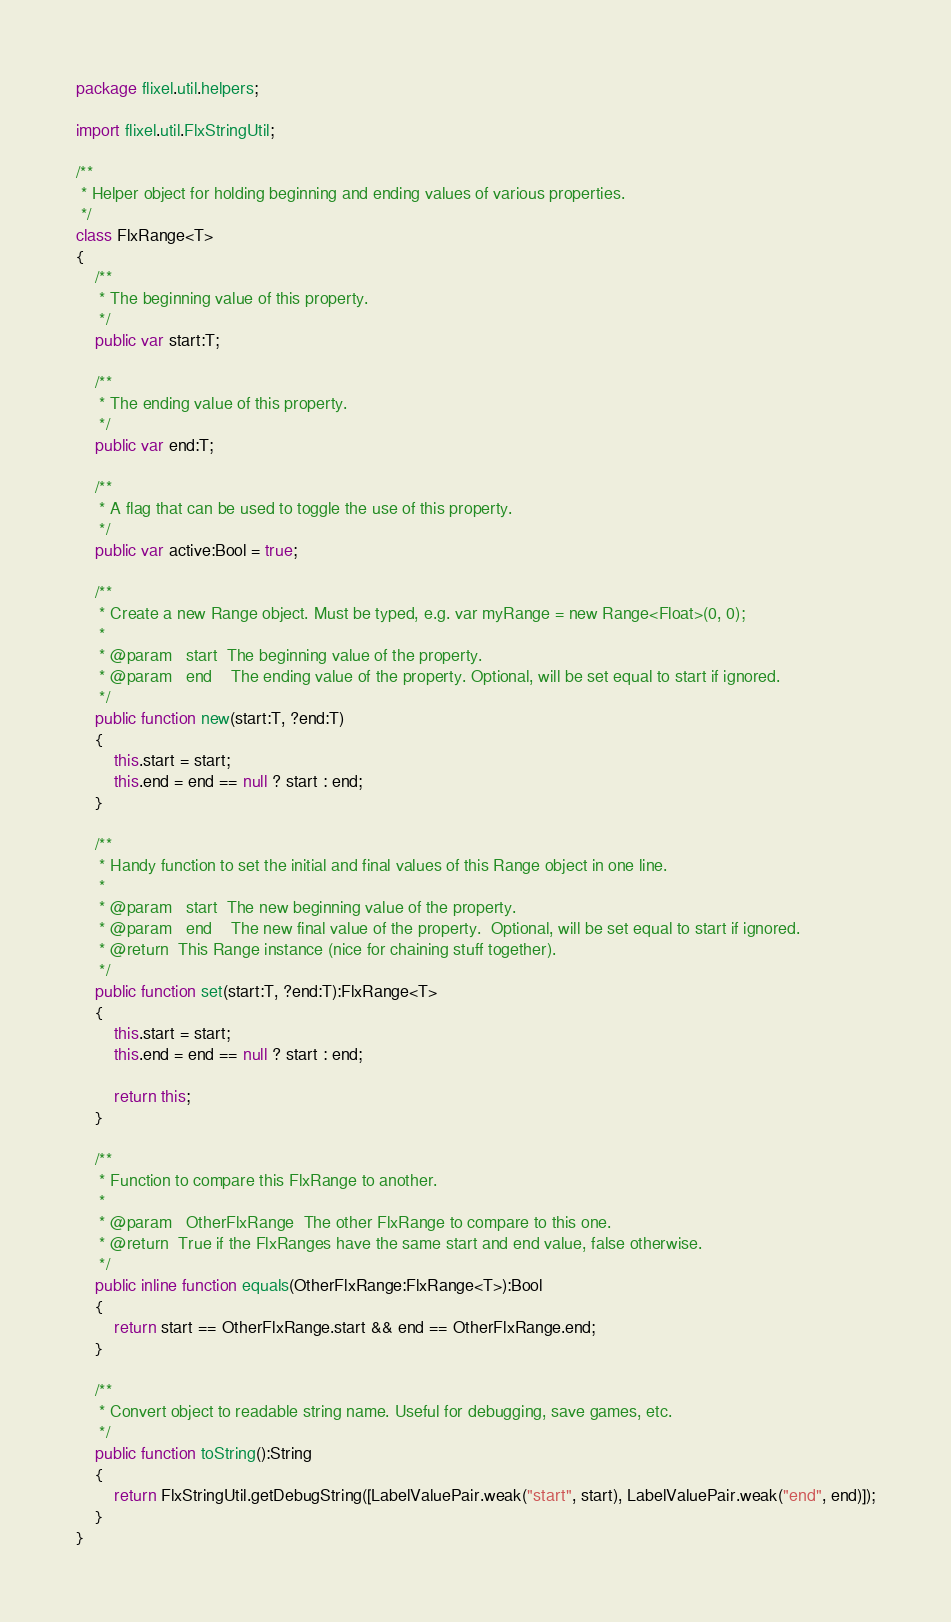<code> <loc_0><loc_0><loc_500><loc_500><_Haxe_>package flixel.util.helpers;

import flixel.util.FlxStringUtil;

/**
 * Helper object for holding beginning and ending values of various properties.
 */
class FlxRange<T>
{
	/**
	 * The beginning value of this property.
	 */
	public var start:T;

	/**
	 * The ending value of this property.
	 */
	public var end:T;

	/**
	 * A flag that can be used to toggle the use of this property.
	 */
	public var active:Bool = true;

	/**
	 * Create a new Range object. Must be typed, e.g. var myRange = new Range<Float>(0, 0);
	 *
	 * @param	start  The beginning value of the property.
	 * @param	end    The ending value of the property. Optional, will be set equal to start if ignored.
	 */
	public function new(start:T, ?end:T)
	{
		this.start = start;
		this.end = end == null ? start : end;
	}

	/**
	 * Handy function to set the initial and final values of this Range object in one line.
	 *
	 * @param	start  The new beginning value of the property.
	 * @param	end    The new final value of the property.  Optional, will be set equal to start if ignored.
	 * @return  This Range instance (nice for chaining stuff together).
	 */
	public function set(start:T, ?end:T):FlxRange<T>
	{
		this.start = start;
		this.end = end == null ? start : end;

		return this;
	}

	/**
	 * Function to compare this FlxRange to another.
	 *
	 * @param	OtherFlxRange  The other FlxRange to compare to this one.
	 * @return	True if the FlxRanges have the same start and end value, false otherwise.
	 */
	public inline function equals(OtherFlxRange:FlxRange<T>):Bool
	{
		return start == OtherFlxRange.start && end == OtherFlxRange.end;
	}

	/**
	 * Convert object to readable string name. Useful for debugging, save games, etc.
	 */
	public function toString():String
	{
		return FlxStringUtil.getDebugString([LabelValuePair.weak("start", start), LabelValuePair.weak("end", end)]);
	}
}
</code> 